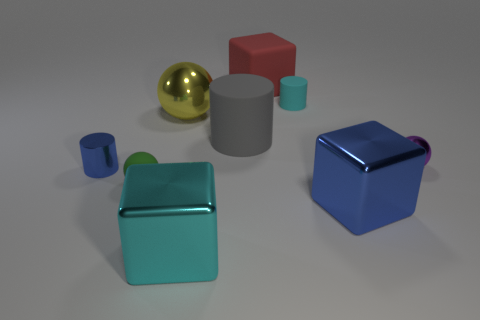What is the shape of the cyan thing behind the tiny sphere right of the shiny block that is on the right side of the gray cylinder?
Make the answer very short. Cylinder. Do the tiny sphere that is to the left of the tiny metallic ball and the tiny sphere behind the blue cylinder have the same material?
Offer a very short reply. No. Are there the same number of small cylinders in front of the green object and small blue shiny cylinders that are on the left side of the small blue metal thing?
Ensure brevity in your answer.  Yes. How many metallic cubes are the same color as the large metal sphere?
Your answer should be very brief. 0. There is a large thing that is the same color as the metallic cylinder; what is its material?
Keep it short and to the point. Metal. What number of matte objects are big yellow spheres or purple spheres?
Your response must be concise. 0. Is the shape of the blue shiny thing that is on the right side of the tiny blue metallic thing the same as the small matte thing on the right side of the gray rubber object?
Ensure brevity in your answer.  No. How many blue things are in front of the small matte ball?
Give a very brief answer. 1. Is there a big sphere that has the same material as the gray object?
Your response must be concise. No. What material is the ball that is the same size as the cyan metal object?
Your answer should be very brief. Metal. 